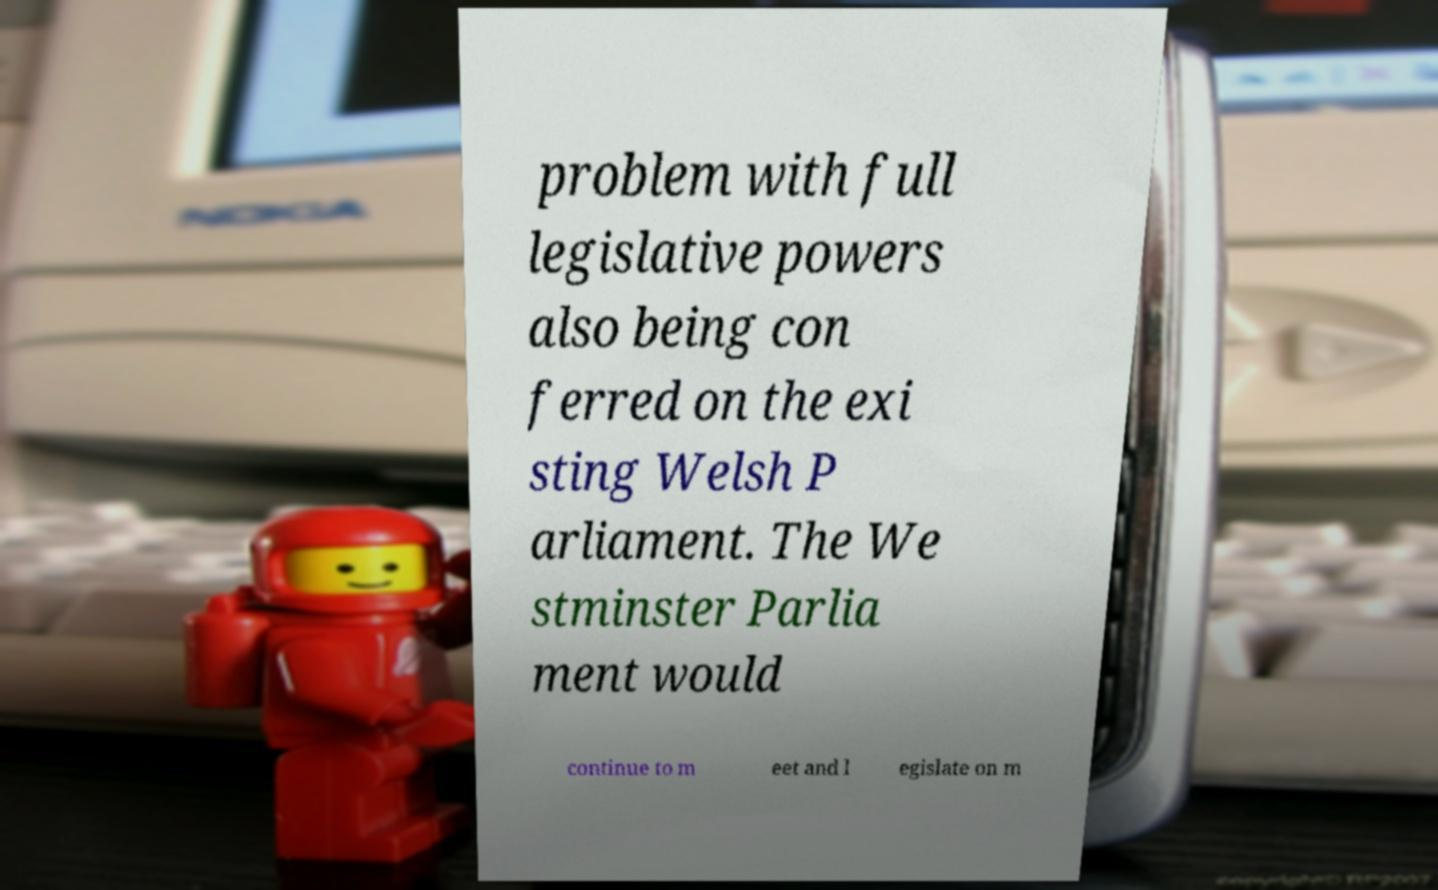For documentation purposes, I need the text within this image transcribed. Could you provide that? problem with full legislative powers also being con ferred on the exi sting Welsh P arliament. The We stminster Parlia ment would continue to m eet and l egislate on m 